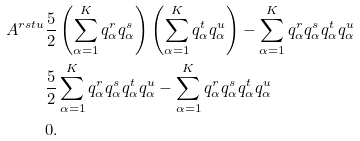Convert formula to latex. <formula><loc_0><loc_0><loc_500><loc_500>A ^ { r s t u } & \frac { 5 } { 2 } \left ( \sum _ { \alpha = 1 } ^ { K } q _ { \alpha } ^ { r } q _ { \alpha } ^ { s } \right ) \left ( \sum _ { \alpha = 1 } ^ { K } q _ { \alpha } ^ { t } q _ { \alpha } ^ { u } \right ) - \sum _ { \alpha = 1 } ^ { K } q _ { \alpha } ^ { r } q _ { \alpha } ^ { s } q _ { \alpha } ^ { t } q _ { \alpha } ^ { u } \\ & \frac { 5 } { 2 } \sum _ { \alpha = 1 } ^ { K } q _ { \alpha } ^ { r } q _ { \alpha } ^ { s } q _ { \alpha } ^ { t } q _ { \alpha } ^ { u } - \sum _ { \alpha = 1 } ^ { K } q _ { \alpha } ^ { r } q _ { \alpha } ^ { s } q _ { \alpha } ^ { t } q _ { \alpha } ^ { u } \\ & 0 .</formula> 